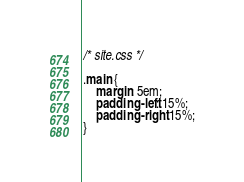Convert code to text. <code><loc_0><loc_0><loc_500><loc_500><_CSS_>/* site.css */

.main {
    margin: 5em;
    padding-left: 15%;
    padding-right: 15%;
}
</code> 